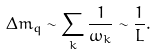Convert formula to latex. <formula><loc_0><loc_0><loc_500><loc_500>\Delta m _ { q } \sim \sum _ { k } \frac { 1 } { \omega _ { k } } \sim \frac { 1 } { L } .</formula> 